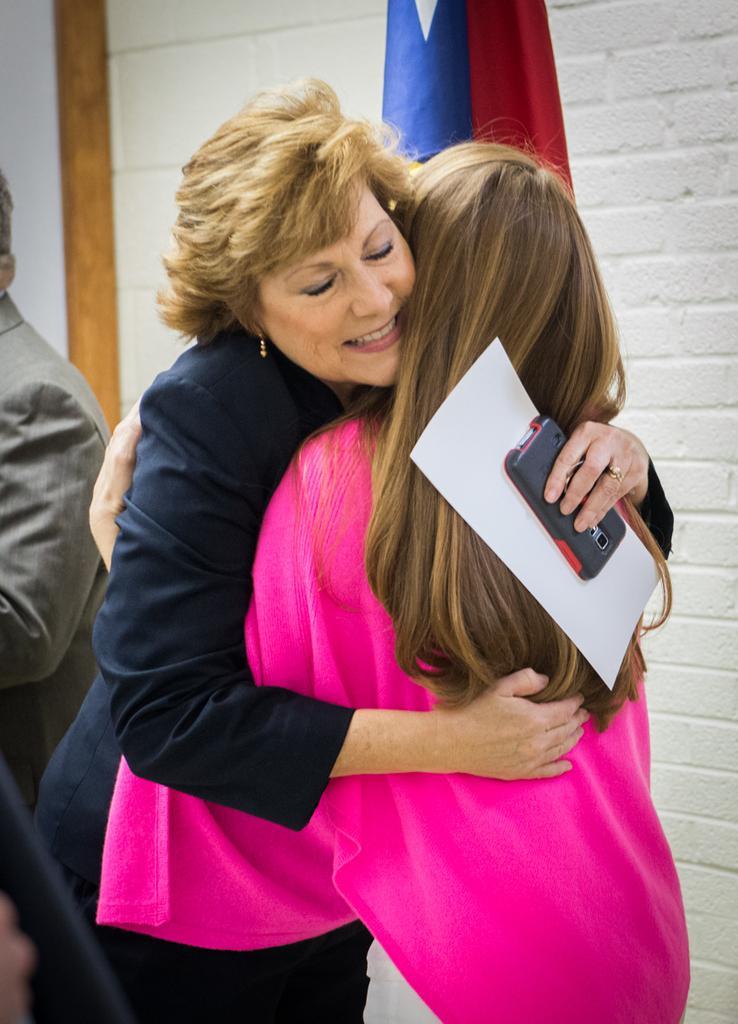Can you describe this image briefly? In the foreground of this picture, there are two women hugging each other and in the background, there is a man, flag and the wall. 